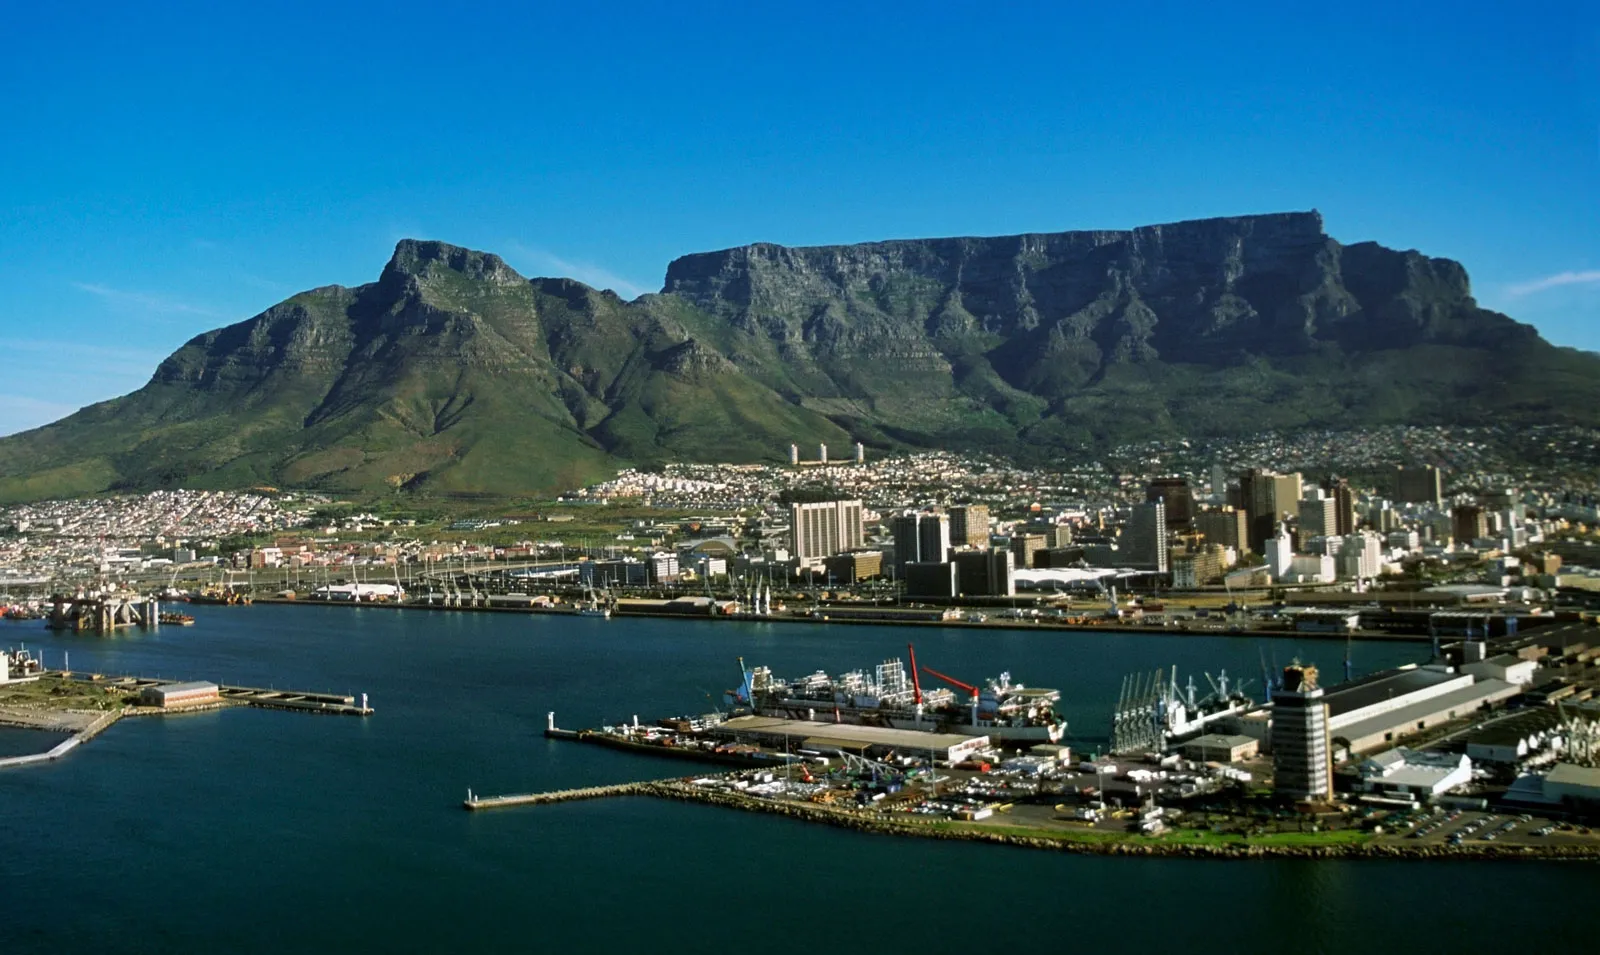What are the key elements in this picture? The photograph showcases the iconic Table Mountain overlooking Cape Town, South Africa, a UNESCO World Heritage site and a symbol of the city's natural beauty. The flat-topped mountain is flanked by Devil's Peak and Lion's Head, standing out against the crisp blue sky. Below, the bustling city is interspersed with verdant spaces, showing a mix of modern urban structures and historical architecture, with the Victoria & Alfred Waterfront visible in the forefront. The harbor with its ships and the adjacent Atlantic Ocean emphasize Cape Town's role as a key economic hub and a maritime gateway to the country. The scene embodies the harmonious blending of natural splendor with the city's lively urban life. 